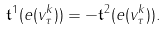<formula> <loc_0><loc_0><loc_500><loc_500>\mathfrak { t } ^ { 1 } ( e ( v _ { \tau } ^ { k } ) ) = - \mathfrak { t } ^ { 2 } ( e ( v _ { \tau } ^ { k } ) ) .</formula> 